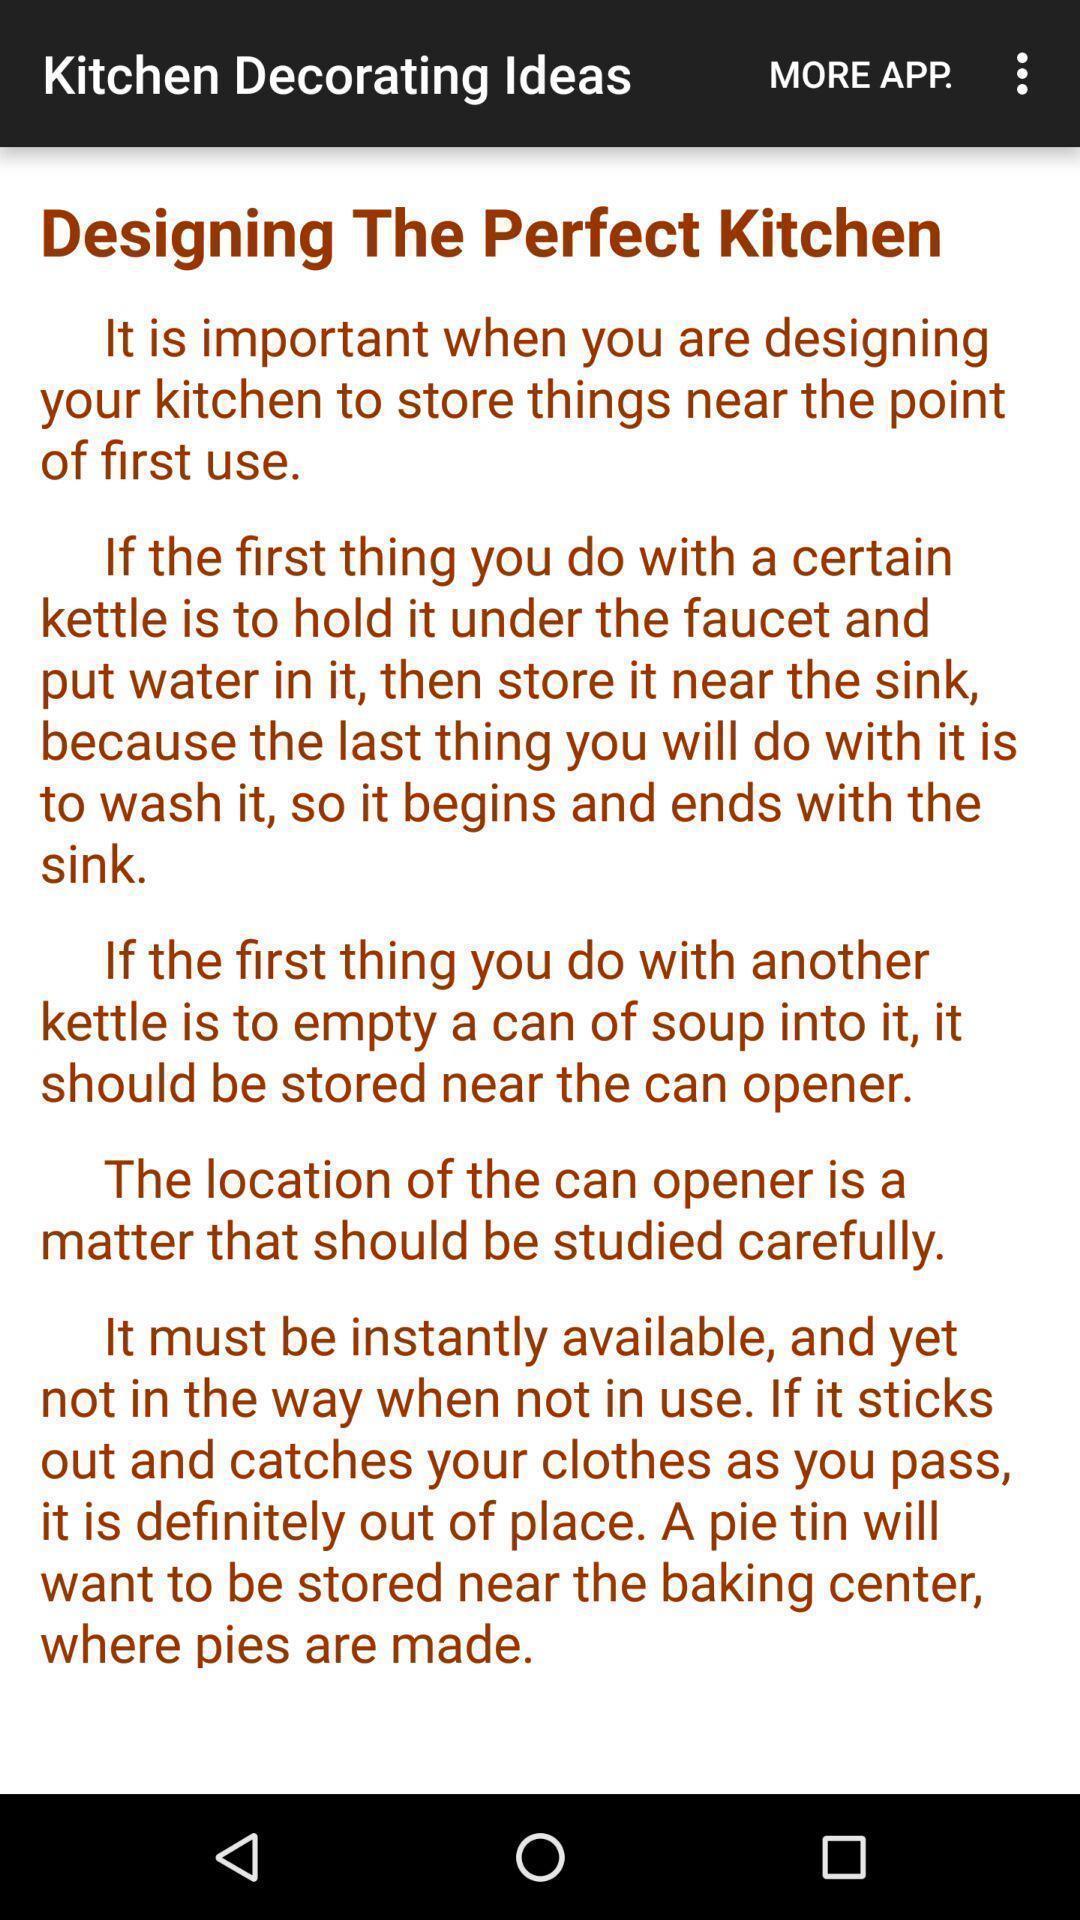Provide a detailed account of this screenshot. Screen displaying the kitchen decorating ideas. 